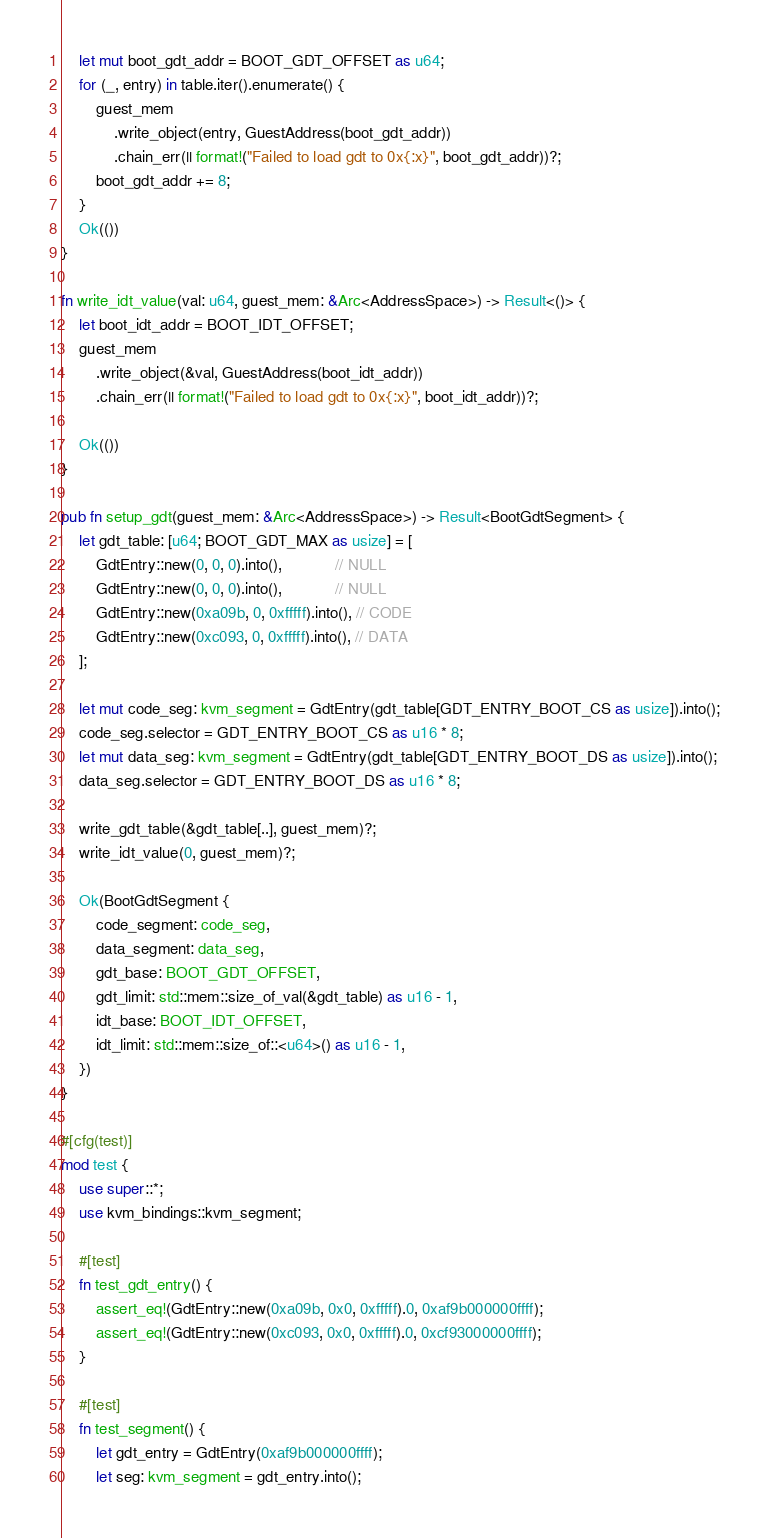<code> <loc_0><loc_0><loc_500><loc_500><_Rust_>    let mut boot_gdt_addr = BOOT_GDT_OFFSET as u64;
    for (_, entry) in table.iter().enumerate() {
        guest_mem
            .write_object(entry, GuestAddress(boot_gdt_addr))
            .chain_err(|| format!("Failed to load gdt to 0x{:x}", boot_gdt_addr))?;
        boot_gdt_addr += 8;
    }
    Ok(())
}

fn write_idt_value(val: u64, guest_mem: &Arc<AddressSpace>) -> Result<()> {
    let boot_idt_addr = BOOT_IDT_OFFSET;
    guest_mem
        .write_object(&val, GuestAddress(boot_idt_addr))
        .chain_err(|| format!("Failed to load gdt to 0x{:x}", boot_idt_addr))?;

    Ok(())
}

pub fn setup_gdt(guest_mem: &Arc<AddressSpace>) -> Result<BootGdtSegment> {
    let gdt_table: [u64; BOOT_GDT_MAX as usize] = [
        GdtEntry::new(0, 0, 0).into(),            // NULL
        GdtEntry::new(0, 0, 0).into(),            // NULL
        GdtEntry::new(0xa09b, 0, 0xfffff).into(), // CODE
        GdtEntry::new(0xc093, 0, 0xfffff).into(), // DATA
    ];

    let mut code_seg: kvm_segment = GdtEntry(gdt_table[GDT_ENTRY_BOOT_CS as usize]).into();
    code_seg.selector = GDT_ENTRY_BOOT_CS as u16 * 8;
    let mut data_seg: kvm_segment = GdtEntry(gdt_table[GDT_ENTRY_BOOT_DS as usize]).into();
    data_seg.selector = GDT_ENTRY_BOOT_DS as u16 * 8;

    write_gdt_table(&gdt_table[..], guest_mem)?;
    write_idt_value(0, guest_mem)?;

    Ok(BootGdtSegment {
        code_segment: code_seg,
        data_segment: data_seg,
        gdt_base: BOOT_GDT_OFFSET,
        gdt_limit: std::mem::size_of_val(&gdt_table) as u16 - 1,
        idt_base: BOOT_IDT_OFFSET,
        idt_limit: std::mem::size_of::<u64>() as u16 - 1,
    })
}

#[cfg(test)]
mod test {
    use super::*;
    use kvm_bindings::kvm_segment;

    #[test]
    fn test_gdt_entry() {
        assert_eq!(GdtEntry::new(0xa09b, 0x0, 0xfffff).0, 0xaf9b000000ffff);
        assert_eq!(GdtEntry::new(0xc093, 0x0, 0xfffff).0, 0xcf93000000ffff);
    }

    #[test]
    fn test_segment() {
        let gdt_entry = GdtEntry(0xaf9b000000ffff);
        let seg: kvm_segment = gdt_entry.into();
</code> 